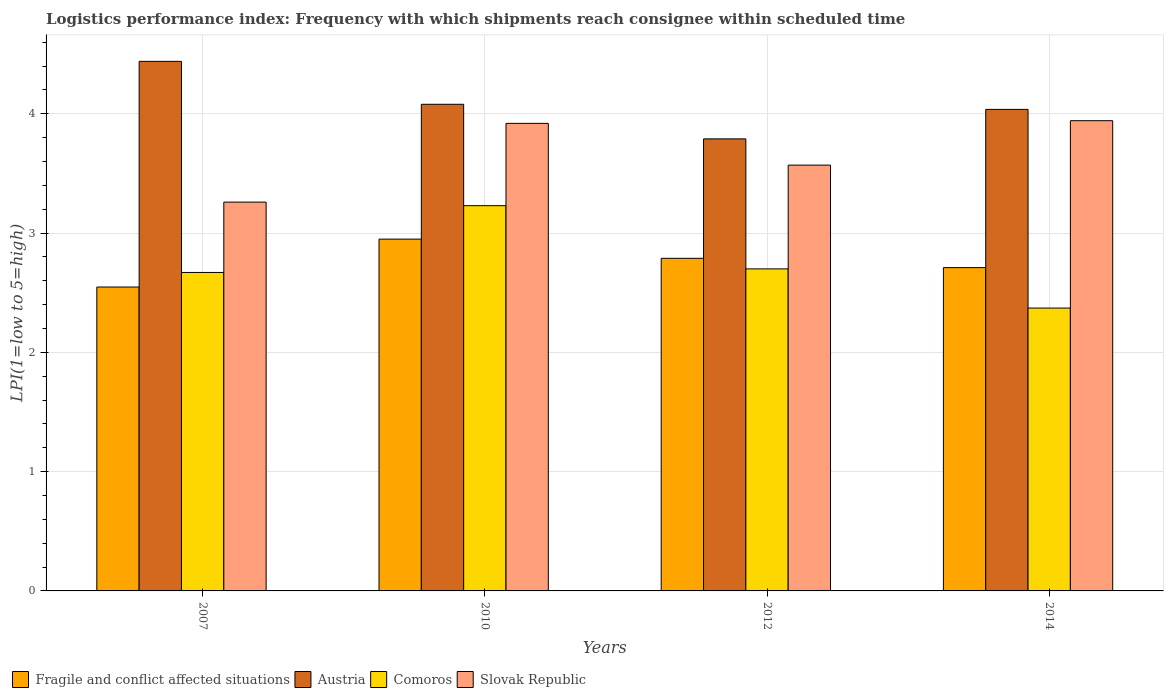How many different coloured bars are there?
Your response must be concise. 4. How many groups of bars are there?
Provide a short and direct response. 4. How many bars are there on the 4th tick from the left?
Offer a terse response. 4. How many bars are there on the 4th tick from the right?
Your answer should be very brief. 4. What is the logistics performance index in Slovak Republic in 2012?
Keep it short and to the point. 3.57. Across all years, what is the maximum logistics performance index in Comoros?
Provide a short and direct response. 3.23. Across all years, what is the minimum logistics performance index in Slovak Republic?
Provide a short and direct response. 3.26. In which year was the logistics performance index in Slovak Republic maximum?
Keep it short and to the point. 2014. In which year was the logistics performance index in Comoros minimum?
Give a very brief answer. 2014. What is the total logistics performance index in Fragile and conflict affected situations in the graph?
Keep it short and to the point. 11. What is the difference between the logistics performance index in Slovak Republic in 2010 and that in 2014?
Make the answer very short. -0.02. What is the difference between the logistics performance index in Slovak Republic in 2014 and the logistics performance index in Fragile and conflict affected situations in 2012?
Your answer should be compact. 1.15. What is the average logistics performance index in Austria per year?
Offer a very short reply. 4.09. In the year 2010, what is the difference between the logistics performance index in Slovak Republic and logistics performance index in Comoros?
Your answer should be compact. 0.69. In how many years, is the logistics performance index in Slovak Republic greater than 0.8?
Keep it short and to the point. 4. What is the ratio of the logistics performance index in Slovak Republic in 2007 to that in 2012?
Make the answer very short. 0.91. What is the difference between the highest and the second highest logistics performance index in Comoros?
Give a very brief answer. 0.53. What is the difference between the highest and the lowest logistics performance index in Comoros?
Provide a short and direct response. 0.86. What does the 1st bar from the left in 2007 represents?
Provide a succinct answer. Fragile and conflict affected situations. What does the 3rd bar from the right in 2010 represents?
Keep it short and to the point. Austria. How many bars are there?
Offer a terse response. 16. Are all the bars in the graph horizontal?
Offer a very short reply. No. How many years are there in the graph?
Keep it short and to the point. 4. What is the difference between two consecutive major ticks on the Y-axis?
Your response must be concise. 1. Are the values on the major ticks of Y-axis written in scientific E-notation?
Your answer should be very brief. No. Where does the legend appear in the graph?
Provide a succinct answer. Bottom left. How many legend labels are there?
Offer a terse response. 4. What is the title of the graph?
Your response must be concise. Logistics performance index: Frequency with which shipments reach consignee within scheduled time. Does "Liberia" appear as one of the legend labels in the graph?
Make the answer very short. No. What is the label or title of the Y-axis?
Offer a very short reply. LPI(1=low to 5=high). What is the LPI(1=low to 5=high) of Fragile and conflict affected situations in 2007?
Your response must be concise. 2.55. What is the LPI(1=low to 5=high) in Austria in 2007?
Make the answer very short. 4.44. What is the LPI(1=low to 5=high) in Comoros in 2007?
Offer a terse response. 2.67. What is the LPI(1=low to 5=high) of Slovak Republic in 2007?
Keep it short and to the point. 3.26. What is the LPI(1=low to 5=high) of Fragile and conflict affected situations in 2010?
Keep it short and to the point. 2.95. What is the LPI(1=low to 5=high) of Austria in 2010?
Your answer should be very brief. 4.08. What is the LPI(1=low to 5=high) of Comoros in 2010?
Your answer should be compact. 3.23. What is the LPI(1=low to 5=high) of Slovak Republic in 2010?
Offer a terse response. 3.92. What is the LPI(1=low to 5=high) in Fragile and conflict affected situations in 2012?
Offer a terse response. 2.79. What is the LPI(1=low to 5=high) of Austria in 2012?
Your answer should be compact. 3.79. What is the LPI(1=low to 5=high) in Comoros in 2012?
Make the answer very short. 2.7. What is the LPI(1=low to 5=high) in Slovak Republic in 2012?
Your answer should be very brief. 3.57. What is the LPI(1=low to 5=high) of Fragile and conflict affected situations in 2014?
Keep it short and to the point. 2.71. What is the LPI(1=low to 5=high) in Austria in 2014?
Keep it short and to the point. 4.04. What is the LPI(1=low to 5=high) of Comoros in 2014?
Your response must be concise. 2.37. What is the LPI(1=low to 5=high) in Slovak Republic in 2014?
Give a very brief answer. 3.94. Across all years, what is the maximum LPI(1=low to 5=high) in Fragile and conflict affected situations?
Your response must be concise. 2.95. Across all years, what is the maximum LPI(1=low to 5=high) of Austria?
Provide a short and direct response. 4.44. Across all years, what is the maximum LPI(1=low to 5=high) in Comoros?
Make the answer very short. 3.23. Across all years, what is the maximum LPI(1=low to 5=high) in Slovak Republic?
Ensure brevity in your answer.  3.94. Across all years, what is the minimum LPI(1=low to 5=high) in Fragile and conflict affected situations?
Your answer should be very brief. 2.55. Across all years, what is the minimum LPI(1=low to 5=high) of Austria?
Offer a very short reply. 3.79. Across all years, what is the minimum LPI(1=low to 5=high) in Comoros?
Your response must be concise. 2.37. Across all years, what is the minimum LPI(1=low to 5=high) in Slovak Republic?
Provide a short and direct response. 3.26. What is the total LPI(1=low to 5=high) of Fragile and conflict affected situations in the graph?
Offer a terse response. 11. What is the total LPI(1=low to 5=high) of Austria in the graph?
Your answer should be very brief. 16.35. What is the total LPI(1=low to 5=high) in Comoros in the graph?
Your answer should be compact. 10.97. What is the total LPI(1=low to 5=high) of Slovak Republic in the graph?
Ensure brevity in your answer.  14.69. What is the difference between the LPI(1=low to 5=high) of Fragile and conflict affected situations in 2007 and that in 2010?
Your answer should be compact. -0.4. What is the difference between the LPI(1=low to 5=high) in Austria in 2007 and that in 2010?
Provide a short and direct response. 0.36. What is the difference between the LPI(1=low to 5=high) in Comoros in 2007 and that in 2010?
Offer a very short reply. -0.56. What is the difference between the LPI(1=low to 5=high) in Slovak Republic in 2007 and that in 2010?
Provide a short and direct response. -0.66. What is the difference between the LPI(1=low to 5=high) in Fragile and conflict affected situations in 2007 and that in 2012?
Your response must be concise. -0.24. What is the difference between the LPI(1=low to 5=high) in Austria in 2007 and that in 2012?
Your response must be concise. 0.65. What is the difference between the LPI(1=low to 5=high) in Comoros in 2007 and that in 2012?
Offer a terse response. -0.03. What is the difference between the LPI(1=low to 5=high) in Slovak Republic in 2007 and that in 2012?
Ensure brevity in your answer.  -0.31. What is the difference between the LPI(1=low to 5=high) of Fragile and conflict affected situations in 2007 and that in 2014?
Keep it short and to the point. -0.16. What is the difference between the LPI(1=low to 5=high) in Austria in 2007 and that in 2014?
Give a very brief answer. 0.4. What is the difference between the LPI(1=low to 5=high) of Comoros in 2007 and that in 2014?
Provide a short and direct response. 0.3. What is the difference between the LPI(1=low to 5=high) in Slovak Republic in 2007 and that in 2014?
Your answer should be very brief. -0.68. What is the difference between the LPI(1=low to 5=high) of Fragile and conflict affected situations in 2010 and that in 2012?
Your answer should be very brief. 0.16. What is the difference between the LPI(1=low to 5=high) in Austria in 2010 and that in 2012?
Keep it short and to the point. 0.29. What is the difference between the LPI(1=low to 5=high) of Comoros in 2010 and that in 2012?
Keep it short and to the point. 0.53. What is the difference between the LPI(1=low to 5=high) of Slovak Republic in 2010 and that in 2012?
Give a very brief answer. 0.35. What is the difference between the LPI(1=low to 5=high) of Fragile and conflict affected situations in 2010 and that in 2014?
Offer a terse response. 0.24. What is the difference between the LPI(1=low to 5=high) of Austria in 2010 and that in 2014?
Give a very brief answer. 0.04. What is the difference between the LPI(1=low to 5=high) in Comoros in 2010 and that in 2014?
Give a very brief answer. 0.86. What is the difference between the LPI(1=low to 5=high) of Slovak Republic in 2010 and that in 2014?
Your answer should be compact. -0.02. What is the difference between the LPI(1=low to 5=high) of Fragile and conflict affected situations in 2012 and that in 2014?
Offer a very short reply. 0.08. What is the difference between the LPI(1=low to 5=high) of Austria in 2012 and that in 2014?
Provide a succinct answer. -0.25. What is the difference between the LPI(1=low to 5=high) of Comoros in 2012 and that in 2014?
Offer a very short reply. 0.33. What is the difference between the LPI(1=low to 5=high) in Slovak Republic in 2012 and that in 2014?
Keep it short and to the point. -0.37. What is the difference between the LPI(1=low to 5=high) of Fragile and conflict affected situations in 2007 and the LPI(1=low to 5=high) of Austria in 2010?
Your answer should be very brief. -1.53. What is the difference between the LPI(1=low to 5=high) in Fragile and conflict affected situations in 2007 and the LPI(1=low to 5=high) in Comoros in 2010?
Provide a short and direct response. -0.68. What is the difference between the LPI(1=low to 5=high) of Fragile and conflict affected situations in 2007 and the LPI(1=low to 5=high) of Slovak Republic in 2010?
Offer a very short reply. -1.37. What is the difference between the LPI(1=low to 5=high) in Austria in 2007 and the LPI(1=low to 5=high) in Comoros in 2010?
Keep it short and to the point. 1.21. What is the difference between the LPI(1=low to 5=high) in Austria in 2007 and the LPI(1=low to 5=high) in Slovak Republic in 2010?
Your answer should be very brief. 0.52. What is the difference between the LPI(1=low to 5=high) in Comoros in 2007 and the LPI(1=low to 5=high) in Slovak Republic in 2010?
Provide a short and direct response. -1.25. What is the difference between the LPI(1=low to 5=high) in Fragile and conflict affected situations in 2007 and the LPI(1=low to 5=high) in Austria in 2012?
Offer a very short reply. -1.24. What is the difference between the LPI(1=low to 5=high) in Fragile and conflict affected situations in 2007 and the LPI(1=low to 5=high) in Comoros in 2012?
Offer a very short reply. -0.15. What is the difference between the LPI(1=low to 5=high) of Fragile and conflict affected situations in 2007 and the LPI(1=low to 5=high) of Slovak Republic in 2012?
Ensure brevity in your answer.  -1.02. What is the difference between the LPI(1=low to 5=high) in Austria in 2007 and the LPI(1=low to 5=high) in Comoros in 2012?
Give a very brief answer. 1.74. What is the difference between the LPI(1=low to 5=high) in Austria in 2007 and the LPI(1=low to 5=high) in Slovak Republic in 2012?
Offer a very short reply. 0.87. What is the difference between the LPI(1=low to 5=high) in Comoros in 2007 and the LPI(1=low to 5=high) in Slovak Republic in 2012?
Make the answer very short. -0.9. What is the difference between the LPI(1=low to 5=high) of Fragile and conflict affected situations in 2007 and the LPI(1=low to 5=high) of Austria in 2014?
Give a very brief answer. -1.49. What is the difference between the LPI(1=low to 5=high) of Fragile and conflict affected situations in 2007 and the LPI(1=low to 5=high) of Comoros in 2014?
Provide a succinct answer. 0.18. What is the difference between the LPI(1=low to 5=high) in Fragile and conflict affected situations in 2007 and the LPI(1=low to 5=high) in Slovak Republic in 2014?
Keep it short and to the point. -1.39. What is the difference between the LPI(1=low to 5=high) in Austria in 2007 and the LPI(1=low to 5=high) in Comoros in 2014?
Offer a very short reply. 2.07. What is the difference between the LPI(1=low to 5=high) in Austria in 2007 and the LPI(1=low to 5=high) in Slovak Republic in 2014?
Your answer should be compact. 0.5. What is the difference between the LPI(1=low to 5=high) of Comoros in 2007 and the LPI(1=low to 5=high) of Slovak Republic in 2014?
Your answer should be very brief. -1.27. What is the difference between the LPI(1=low to 5=high) of Fragile and conflict affected situations in 2010 and the LPI(1=low to 5=high) of Austria in 2012?
Offer a very short reply. -0.84. What is the difference between the LPI(1=low to 5=high) of Fragile and conflict affected situations in 2010 and the LPI(1=low to 5=high) of Comoros in 2012?
Make the answer very short. 0.25. What is the difference between the LPI(1=low to 5=high) in Fragile and conflict affected situations in 2010 and the LPI(1=low to 5=high) in Slovak Republic in 2012?
Your response must be concise. -0.62. What is the difference between the LPI(1=low to 5=high) in Austria in 2010 and the LPI(1=low to 5=high) in Comoros in 2012?
Provide a succinct answer. 1.38. What is the difference between the LPI(1=low to 5=high) of Austria in 2010 and the LPI(1=low to 5=high) of Slovak Republic in 2012?
Make the answer very short. 0.51. What is the difference between the LPI(1=low to 5=high) of Comoros in 2010 and the LPI(1=low to 5=high) of Slovak Republic in 2012?
Your response must be concise. -0.34. What is the difference between the LPI(1=low to 5=high) of Fragile and conflict affected situations in 2010 and the LPI(1=low to 5=high) of Austria in 2014?
Ensure brevity in your answer.  -1.09. What is the difference between the LPI(1=low to 5=high) in Fragile and conflict affected situations in 2010 and the LPI(1=low to 5=high) in Comoros in 2014?
Provide a short and direct response. 0.58. What is the difference between the LPI(1=low to 5=high) of Fragile and conflict affected situations in 2010 and the LPI(1=low to 5=high) of Slovak Republic in 2014?
Keep it short and to the point. -0.99. What is the difference between the LPI(1=low to 5=high) in Austria in 2010 and the LPI(1=low to 5=high) in Comoros in 2014?
Give a very brief answer. 1.71. What is the difference between the LPI(1=low to 5=high) of Austria in 2010 and the LPI(1=low to 5=high) of Slovak Republic in 2014?
Provide a succinct answer. 0.14. What is the difference between the LPI(1=low to 5=high) in Comoros in 2010 and the LPI(1=low to 5=high) in Slovak Republic in 2014?
Provide a succinct answer. -0.71. What is the difference between the LPI(1=low to 5=high) of Fragile and conflict affected situations in 2012 and the LPI(1=low to 5=high) of Austria in 2014?
Keep it short and to the point. -1.25. What is the difference between the LPI(1=low to 5=high) of Fragile and conflict affected situations in 2012 and the LPI(1=low to 5=high) of Comoros in 2014?
Offer a very short reply. 0.42. What is the difference between the LPI(1=low to 5=high) in Fragile and conflict affected situations in 2012 and the LPI(1=low to 5=high) in Slovak Republic in 2014?
Offer a terse response. -1.15. What is the difference between the LPI(1=low to 5=high) in Austria in 2012 and the LPI(1=low to 5=high) in Comoros in 2014?
Ensure brevity in your answer.  1.42. What is the difference between the LPI(1=low to 5=high) in Austria in 2012 and the LPI(1=low to 5=high) in Slovak Republic in 2014?
Make the answer very short. -0.15. What is the difference between the LPI(1=low to 5=high) of Comoros in 2012 and the LPI(1=low to 5=high) of Slovak Republic in 2014?
Your answer should be very brief. -1.24. What is the average LPI(1=low to 5=high) in Fragile and conflict affected situations per year?
Offer a very short reply. 2.75. What is the average LPI(1=low to 5=high) in Austria per year?
Provide a short and direct response. 4.09. What is the average LPI(1=low to 5=high) in Comoros per year?
Your answer should be compact. 2.74. What is the average LPI(1=low to 5=high) in Slovak Republic per year?
Offer a very short reply. 3.67. In the year 2007, what is the difference between the LPI(1=low to 5=high) in Fragile and conflict affected situations and LPI(1=low to 5=high) in Austria?
Your answer should be compact. -1.89. In the year 2007, what is the difference between the LPI(1=low to 5=high) in Fragile and conflict affected situations and LPI(1=low to 5=high) in Comoros?
Ensure brevity in your answer.  -0.12. In the year 2007, what is the difference between the LPI(1=low to 5=high) of Fragile and conflict affected situations and LPI(1=low to 5=high) of Slovak Republic?
Your answer should be very brief. -0.71. In the year 2007, what is the difference between the LPI(1=low to 5=high) in Austria and LPI(1=low to 5=high) in Comoros?
Your answer should be very brief. 1.77. In the year 2007, what is the difference between the LPI(1=low to 5=high) of Austria and LPI(1=low to 5=high) of Slovak Republic?
Offer a terse response. 1.18. In the year 2007, what is the difference between the LPI(1=low to 5=high) of Comoros and LPI(1=low to 5=high) of Slovak Republic?
Provide a short and direct response. -0.59. In the year 2010, what is the difference between the LPI(1=low to 5=high) in Fragile and conflict affected situations and LPI(1=low to 5=high) in Austria?
Ensure brevity in your answer.  -1.13. In the year 2010, what is the difference between the LPI(1=low to 5=high) of Fragile and conflict affected situations and LPI(1=low to 5=high) of Comoros?
Keep it short and to the point. -0.28. In the year 2010, what is the difference between the LPI(1=low to 5=high) of Fragile and conflict affected situations and LPI(1=low to 5=high) of Slovak Republic?
Your answer should be compact. -0.97. In the year 2010, what is the difference between the LPI(1=low to 5=high) of Austria and LPI(1=low to 5=high) of Slovak Republic?
Your response must be concise. 0.16. In the year 2010, what is the difference between the LPI(1=low to 5=high) of Comoros and LPI(1=low to 5=high) of Slovak Republic?
Provide a short and direct response. -0.69. In the year 2012, what is the difference between the LPI(1=low to 5=high) of Fragile and conflict affected situations and LPI(1=low to 5=high) of Austria?
Your answer should be compact. -1. In the year 2012, what is the difference between the LPI(1=low to 5=high) of Fragile and conflict affected situations and LPI(1=low to 5=high) of Comoros?
Provide a succinct answer. 0.09. In the year 2012, what is the difference between the LPI(1=low to 5=high) in Fragile and conflict affected situations and LPI(1=low to 5=high) in Slovak Republic?
Give a very brief answer. -0.78. In the year 2012, what is the difference between the LPI(1=low to 5=high) in Austria and LPI(1=low to 5=high) in Comoros?
Offer a very short reply. 1.09. In the year 2012, what is the difference between the LPI(1=low to 5=high) in Austria and LPI(1=low to 5=high) in Slovak Republic?
Provide a succinct answer. 0.22. In the year 2012, what is the difference between the LPI(1=low to 5=high) in Comoros and LPI(1=low to 5=high) in Slovak Republic?
Make the answer very short. -0.87. In the year 2014, what is the difference between the LPI(1=low to 5=high) of Fragile and conflict affected situations and LPI(1=low to 5=high) of Austria?
Offer a terse response. -1.33. In the year 2014, what is the difference between the LPI(1=low to 5=high) in Fragile and conflict affected situations and LPI(1=low to 5=high) in Comoros?
Keep it short and to the point. 0.34. In the year 2014, what is the difference between the LPI(1=low to 5=high) of Fragile and conflict affected situations and LPI(1=low to 5=high) of Slovak Republic?
Your answer should be very brief. -1.23. In the year 2014, what is the difference between the LPI(1=low to 5=high) in Austria and LPI(1=low to 5=high) in Comoros?
Your response must be concise. 1.67. In the year 2014, what is the difference between the LPI(1=low to 5=high) in Austria and LPI(1=low to 5=high) in Slovak Republic?
Your answer should be very brief. 0.09. In the year 2014, what is the difference between the LPI(1=low to 5=high) of Comoros and LPI(1=low to 5=high) of Slovak Republic?
Your response must be concise. -1.57. What is the ratio of the LPI(1=low to 5=high) of Fragile and conflict affected situations in 2007 to that in 2010?
Your answer should be compact. 0.86. What is the ratio of the LPI(1=low to 5=high) of Austria in 2007 to that in 2010?
Offer a terse response. 1.09. What is the ratio of the LPI(1=low to 5=high) of Comoros in 2007 to that in 2010?
Give a very brief answer. 0.83. What is the ratio of the LPI(1=low to 5=high) in Slovak Republic in 2007 to that in 2010?
Provide a short and direct response. 0.83. What is the ratio of the LPI(1=low to 5=high) in Fragile and conflict affected situations in 2007 to that in 2012?
Provide a short and direct response. 0.91. What is the ratio of the LPI(1=low to 5=high) in Austria in 2007 to that in 2012?
Your answer should be very brief. 1.17. What is the ratio of the LPI(1=low to 5=high) of Comoros in 2007 to that in 2012?
Your response must be concise. 0.99. What is the ratio of the LPI(1=low to 5=high) in Slovak Republic in 2007 to that in 2012?
Give a very brief answer. 0.91. What is the ratio of the LPI(1=low to 5=high) of Fragile and conflict affected situations in 2007 to that in 2014?
Your answer should be compact. 0.94. What is the ratio of the LPI(1=low to 5=high) in Austria in 2007 to that in 2014?
Offer a very short reply. 1.1. What is the ratio of the LPI(1=low to 5=high) of Comoros in 2007 to that in 2014?
Offer a terse response. 1.13. What is the ratio of the LPI(1=low to 5=high) of Slovak Republic in 2007 to that in 2014?
Your response must be concise. 0.83. What is the ratio of the LPI(1=low to 5=high) in Fragile and conflict affected situations in 2010 to that in 2012?
Provide a succinct answer. 1.06. What is the ratio of the LPI(1=low to 5=high) in Austria in 2010 to that in 2012?
Your answer should be very brief. 1.08. What is the ratio of the LPI(1=low to 5=high) in Comoros in 2010 to that in 2012?
Ensure brevity in your answer.  1.2. What is the ratio of the LPI(1=low to 5=high) of Slovak Republic in 2010 to that in 2012?
Provide a succinct answer. 1.1. What is the ratio of the LPI(1=low to 5=high) of Fragile and conflict affected situations in 2010 to that in 2014?
Provide a succinct answer. 1.09. What is the ratio of the LPI(1=low to 5=high) of Austria in 2010 to that in 2014?
Your answer should be very brief. 1.01. What is the ratio of the LPI(1=low to 5=high) of Comoros in 2010 to that in 2014?
Keep it short and to the point. 1.36. What is the ratio of the LPI(1=low to 5=high) of Fragile and conflict affected situations in 2012 to that in 2014?
Your answer should be compact. 1.03. What is the ratio of the LPI(1=low to 5=high) of Austria in 2012 to that in 2014?
Ensure brevity in your answer.  0.94. What is the ratio of the LPI(1=low to 5=high) of Comoros in 2012 to that in 2014?
Provide a succinct answer. 1.14. What is the ratio of the LPI(1=low to 5=high) of Slovak Republic in 2012 to that in 2014?
Give a very brief answer. 0.91. What is the difference between the highest and the second highest LPI(1=low to 5=high) of Fragile and conflict affected situations?
Give a very brief answer. 0.16. What is the difference between the highest and the second highest LPI(1=low to 5=high) of Austria?
Provide a succinct answer. 0.36. What is the difference between the highest and the second highest LPI(1=low to 5=high) of Comoros?
Provide a short and direct response. 0.53. What is the difference between the highest and the second highest LPI(1=low to 5=high) of Slovak Republic?
Make the answer very short. 0.02. What is the difference between the highest and the lowest LPI(1=low to 5=high) in Fragile and conflict affected situations?
Keep it short and to the point. 0.4. What is the difference between the highest and the lowest LPI(1=low to 5=high) of Austria?
Make the answer very short. 0.65. What is the difference between the highest and the lowest LPI(1=low to 5=high) of Comoros?
Your answer should be very brief. 0.86. What is the difference between the highest and the lowest LPI(1=low to 5=high) of Slovak Republic?
Give a very brief answer. 0.68. 